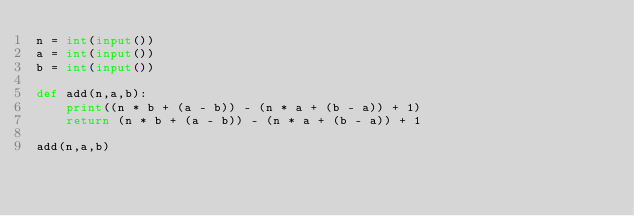Convert code to text. <code><loc_0><loc_0><loc_500><loc_500><_Python_>n = int(input())
a = int(input())
b = int(input())

def add(n,a,b):
    print((n * b + (a - b)) - (n * a + (b - a)) + 1)
    return (n * b + (a - b)) - (n * a + (b - a)) + 1

add(n,a,b)</code> 